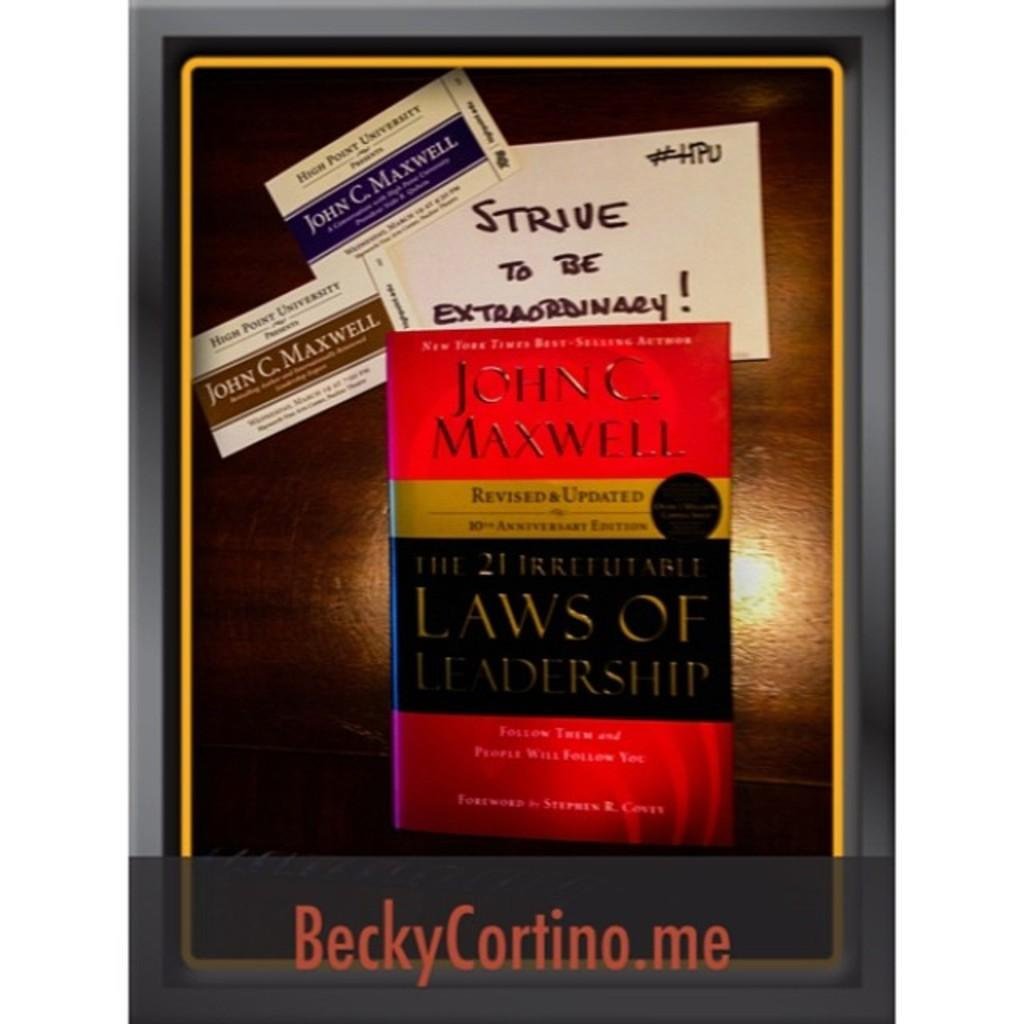What is featured on the poster in the image? The poster has a book and cards on it. What can be seen on the book and cards? The book and cards have text on them. Is there any text visible outside of the poster? Yes, there is text at the bottom of the image. What type of tin can be seen in the image? There is no tin present in the image. How does the cloud affect the poster in the image? There is no cloud present in the image, so it cannot affect the poster. 